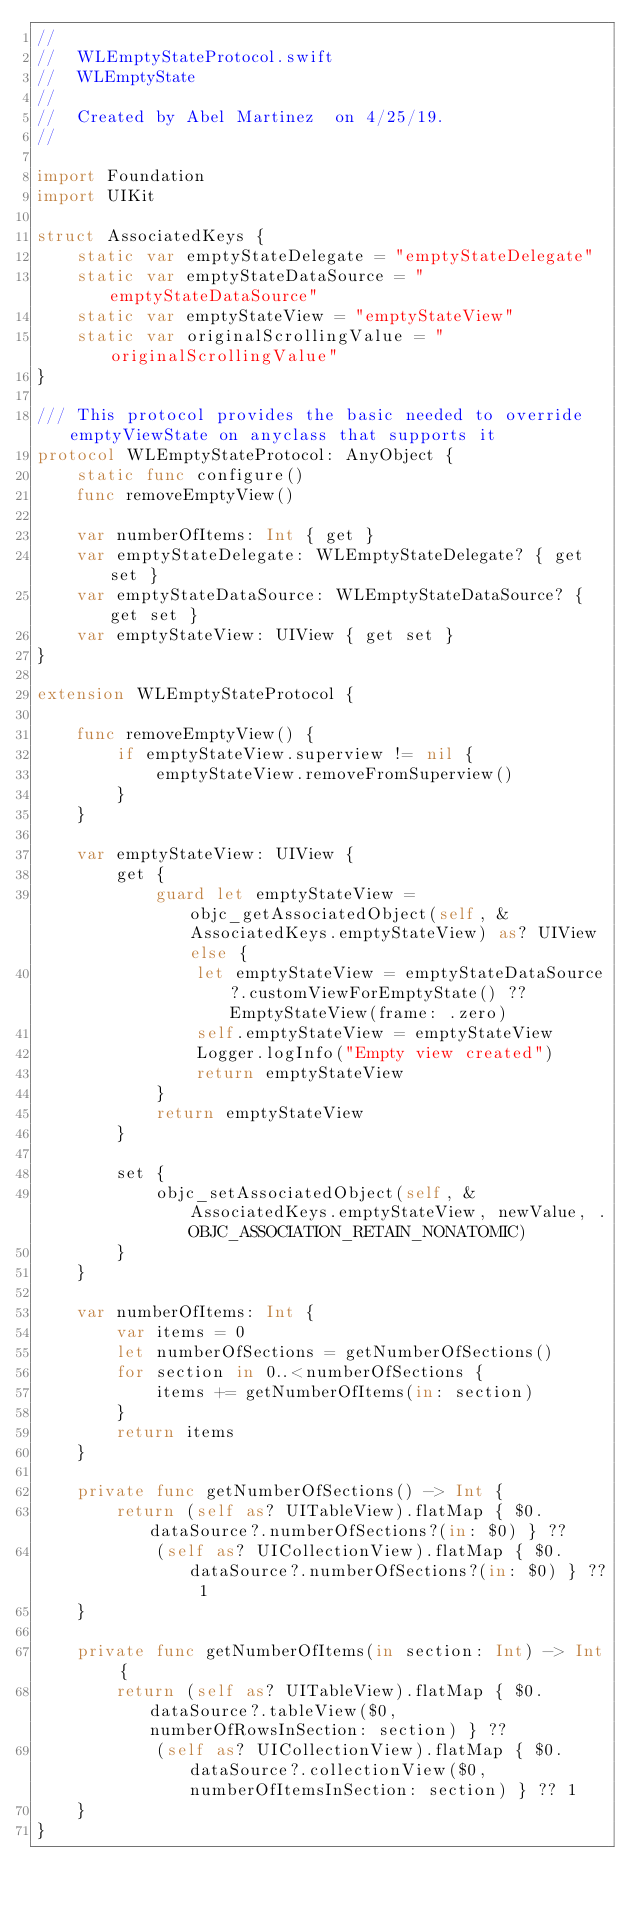<code> <loc_0><loc_0><loc_500><loc_500><_Swift_>//
//  WLEmptyStateProtocol.swift
//  WLEmptyState
//
//  Created by Abel Martinez  on 4/25/19.
//

import Foundation
import UIKit

struct AssociatedKeys {
    static var emptyStateDelegate = "emptyStateDelegate"
    static var emptyStateDataSource = "emptyStateDataSource"
    static var emptyStateView = "emptyStateView"
    static var originalScrollingValue = "originalScrollingValue"
}

/// This protocol provides the basic needed to override emptyViewState on anyclass that supports it
protocol WLEmptyStateProtocol: AnyObject {
    static func configure()
    func removeEmptyView()
    
    var numberOfItems: Int { get }
    var emptyStateDelegate: WLEmptyStateDelegate? { get set }
    var emptyStateDataSource: WLEmptyStateDataSource? { get set }
    var emptyStateView: UIView { get set }
}

extension WLEmptyStateProtocol {
    
    func removeEmptyView() {
        if emptyStateView.superview != nil {
            emptyStateView.removeFromSuperview()
        }
    }
    
    var emptyStateView: UIView {
        get {
            guard let emptyStateView = objc_getAssociatedObject(self, &AssociatedKeys.emptyStateView) as? UIView else {
                let emptyStateView = emptyStateDataSource?.customViewForEmptyState() ?? EmptyStateView(frame: .zero)
                self.emptyStateView = emptyStateView
                Logger.logInfo("Empty view created")
                return emptyStateView
            }
            return emptyStateView
        }
        
        set {
            objc_setAssociatedObject(self, &AssociatedKeys.emptyStateView, newValue, .OBJC_ASSOCIATION_RETAIN_NONATOMIC)
        }
    }
    
    var numberOfItems: Int {
        var items = 0
        let numberOfSections = getNumberOfSections()
        for section in 0..<numberOfSections {
            items += getNumberOfItems(in: section)
        }
        return items
    }
    
    private func getNumberOfSections() -> Int {
        return (self as? UITableView).flatMap { $0.dataSource?.numberOfSections?(in: $0) } ??
            (self as? UICollectionView).flatMap { $0.dataSource?.numberOfSections?(in: $0) } ?? 1
    }
    
    private func getNumberOfItems(in section: Int) -> Int {
        return (self as? UITableView).flatMap { $0.dataSource?.tableView($0, numberOfRowsInSection: section) } ??
            (self as? UICollectionView).flatMap { $0.dataSource?.collectionView($0, numberOfItemsInSection: section) } ?? 1
    }
}
</code> 